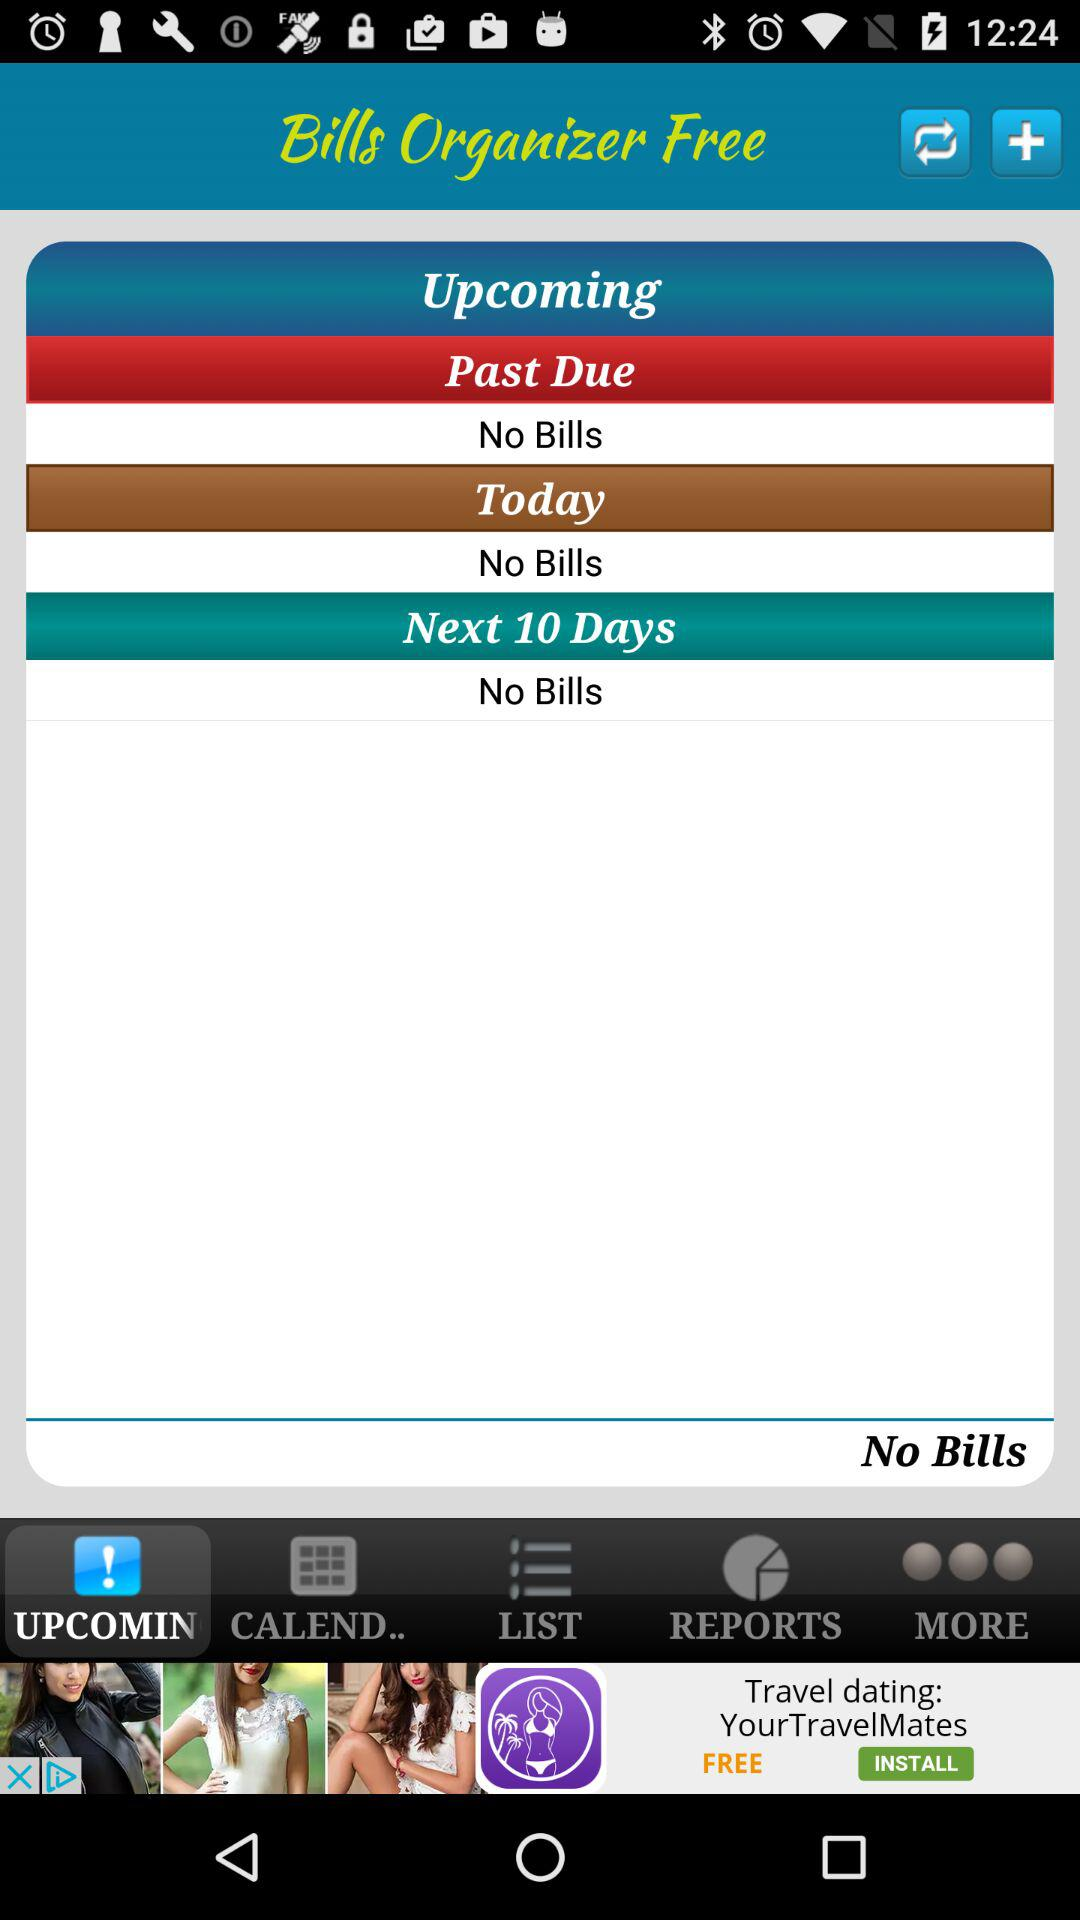How many bills are due between today and the next 10 days?
Answer the question using a single word or phrase. 0 